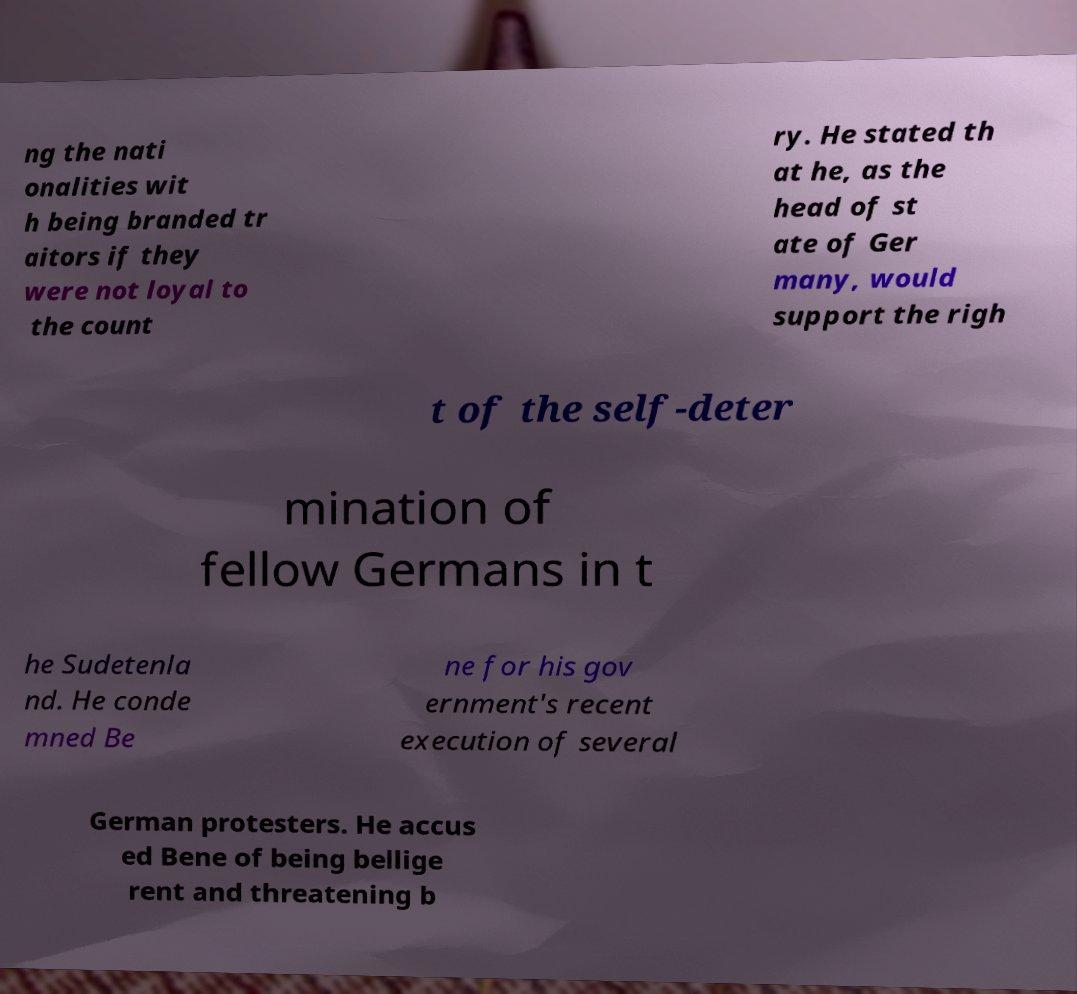There's text embedded in this image that I need extracted. Can you transcribe it verbatim? ng the nati onalities wit h being branded tr aitors if they were not loyal to the count ry. He stated th at he, as the head of st ate of Ger many, would support the righ t of the self-deter mination of fellow Germans in t he Sudetenla nd. He conde mned Be ne for his gov ernment's recent execution of several German protesters. He accus ed Bene of being bellige rent and threatening b 